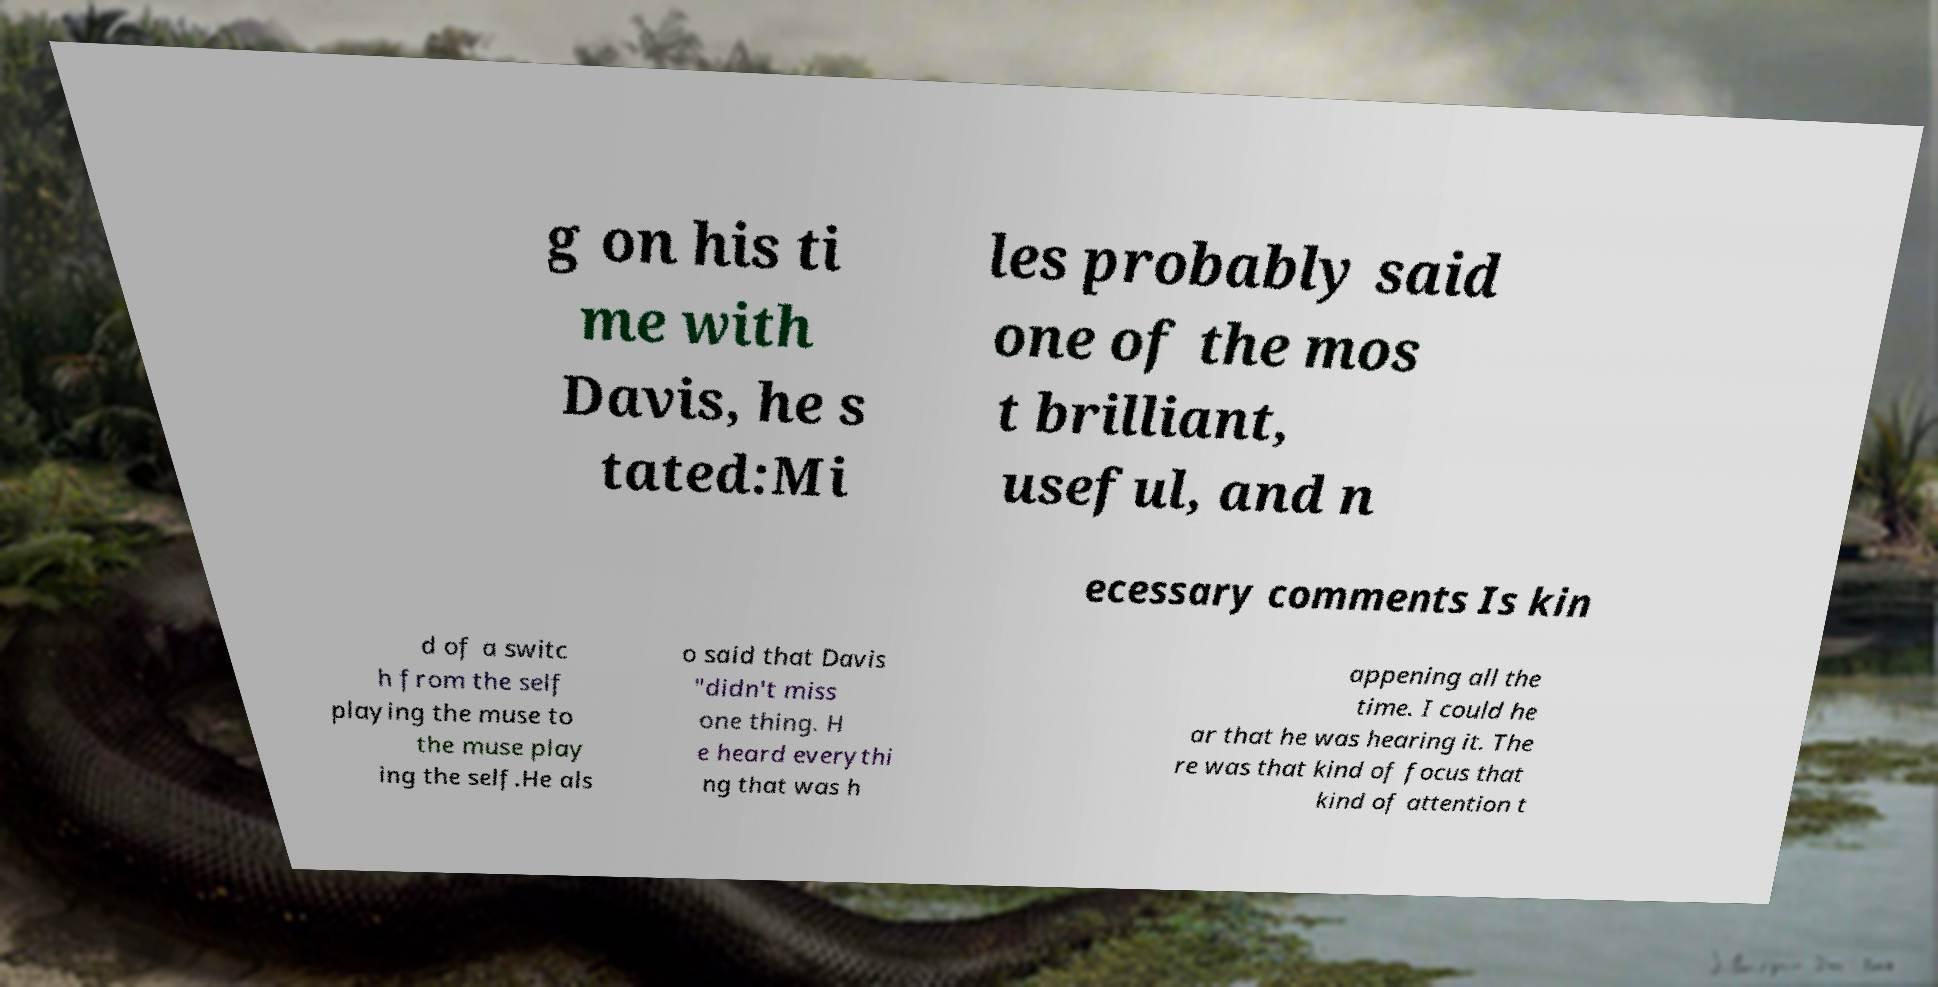Could you extract and type out the text from this image? g on his ti me with Davis, he s tated:Mi les probably said one of the mos t brilliant, useful, and n ecessary comments Is kin d of a switc h from the self playing the muse to the muse play ing the self.He als o said that Davis "didn't miss one thing. H e heard everythi ng that was h appening all the time. I could he ar that he was hearing it. The re was that kind of focus that kind of attention t 